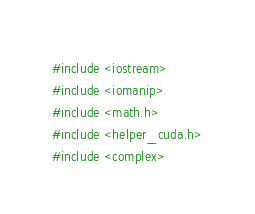Convert code to text. <code><loc_0><loc_0><loc_500><loc_500><_Cuda_>#include <iostream>
#include <iomanip>
#include <math.h>
#include <helper_cuda.h>
#include <complex></code> 